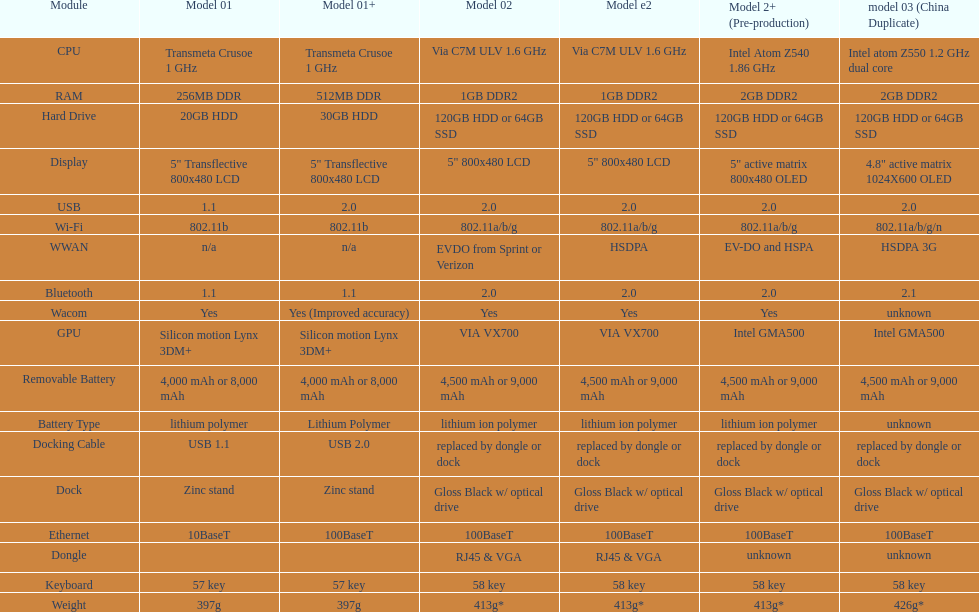0 compatibility? 5. 